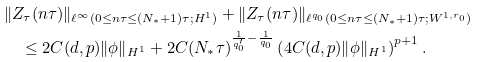Convert formula to latex. <formula><loc_0><loc_0><loc_500><loc_500>& \| Z _ { \tau } ( n \tau ) \| _ { \ell ^ { \infty } ( 0 \leq n \tau \leq ( N _ { * } + 1 ) \tau ; H ^ { 1 } ) } + \| Z _ { \tau } ( n \tau ) \| _ { \ell ^ { q _ { 0 } } ( 0 \leq n \tau \leq ( N _ { * } + 1 ) \tau ; W ^ { 1 , r _ { 0 } } ) } \\ & \quad \leq 2 C ( d , p ) \| \phi \| _ { { H } ^ { 1 } } + 2 C ( N _ { * } \tau ) ^ { \frac { 1 } { q _ { 0 } ^ { \prime } } - \frac { 1 } { q _ { 0 } } } \left ( 4 C ( d , p ) \| \phi \| _ { { H } ^ { 1 } } \right ) ^ { p + 1 } .</formula> 